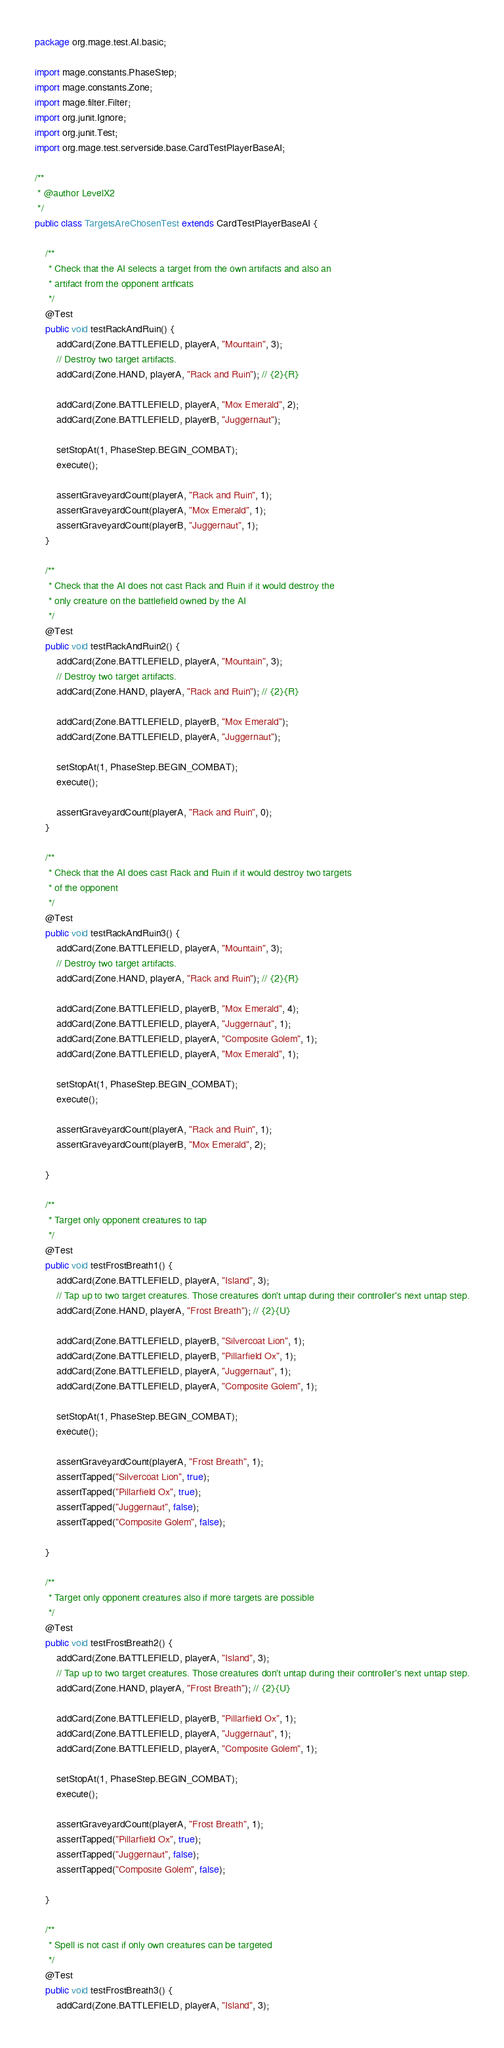Convert code to text. <code><loc_0><loc_0><loc_500><loc_500><_Java_>package org.mage.test.AI.basic;

import mage.constants.PhaseStep;
import mage.constants.Zone;
import mage.filter.Filter;
import org.junit.Ignore;
import org.junit.Test;
import org.mage.test.serverside.base.CardTestPlayerBaseAI;

/**
 * @author LevelX2
 */
public class TargetsAreChosenTest extends CardTestPlayerBaseAI {

    /**
     * Check that the AI selects a target from the own artifacts and also an
     * artifact from the opponent artficats
     */
    @Test
    public void testRackAndRuin() {
        addCard(Zone.BATTLEFIELD, playerA, "Mountain", 3);
        // Destroy two target artifacts.
        addCard(Zone.HAND, playerA, "Rack and Ruin"); // {2}{R}

        addCard(Zone.BATTLEFIELD, playerA, "Mox Emerald", 2);
        addCard(Zone.BATTLEFIELD, playerB, "Juggernaut");

        setStopAt(1, PhaseStep.BEGIN_COMBAT);
        execute();

        assertGraveyardCount(playerA, "Rack and Ruin", 1);
        assertGraveyardCount(playerA, "Mox Emerald", 1);
        assertGraveyardCount(playerB, "Juggernaut", 1);
    }

    /**
     * Check that the AI does not cast Rack and Ruin if it would destroy the
     * only creature on the battlefield owned by the AI
     */
    @Test
    public void testRackAndRuin2() {
        addCard(Zone.BATTLEFIELD, playerA, "Mountain", 3);
        // Destroy two target artifacts.
        addCard(Zone.HAND, playerA, "Rack and Ruin"); // {2}{R}

        addCard(Zone.BATTLEFIELD, playerB, "Mox Emerald");
        addCard(Zone.BATTLEFIELD, playerA, "Juggernaut");

        setStopAt(1, PhaseStep.BEGIN_COMBAT);
        execute();

        assertGraveyardCount(playerA, "Rack and Ruin", 0);
    }

    /**
     * Check that the AI does cast Rack and Ruin if it would destroy two targets
     * of the opponent
     */
    @Test
    public void testRackAndRuin3() {
        addCard(Zone.BATTLEFIELD, playerA, "Mountain", 3);
        // Destroy two target artifacts.
        addCard(Zone.HAND, playerA, "Rack and Ruin"); // {2}{R}

        addCard(Zone.BATTLEFIELD, playerB, "Mox Emerald", 4);
        addCard(Zone.BATTLEFIELD, playerA, "Juggernaut", 1);
        addCard(Zone.BATTLEFIELD, playerA, "Composite Golem", 1);
        addCard(Zone.BATTLEFIELD, playerA, "Mox Emerald", 1);

        setStopAt(1, PhaseStep.BEGIN_COMBAT);
        execute();

        assertGraveyardCount(playerA, "Rack and Ruin", 1);
        assertGraveyardCount(playerB, "Mox Emerald", 2);

    }

    /**
     * Target only opponent creatures to tap
     */
    @Test
    public void testFrostBreath1() {
        addCard(Zone.BATTLEFIELD, playerA, "Island", 3);
        // Tap up to two target creatures. Those creatures don't untap during their controller's next untap step.
        addCard(Zone.HAND, playerA, "Frost Breath"); // {2}{U}

        addCard(Zone.BATTLEFIELD, playerB, "Silvercoat Lion", 1);
        addCard(Zone.BATTLEFIELD, playerB, "Pillarfield Ox", 1);
        addCard(Zone.BATTLEFIELD, playerA, "Juggernaut", 1);
        addCard(Zone.BATTLEFIELD, playerA, "Composite Golem", 1);

        setStopAt(1, PhaseStep.BEGIN_COMBAT);
        execute();

        assertGraveyardCount(playerA, "Frost Breath", 1);
        assertTapped("Silvercoat Lion", true);
        assertTapped("Pillarfield Ox", true);
        assertTapped("Juggernaut", false);
        assertTapped("Composite Golem", false);

    }

    /**
     * Target only opponent creatures also if more targets are possible
     */
    @Test
    public void testFrostBreath2() {
        addCard(Zone.BATTLEFIELD, playerA, "Island", 3);
        // Tap up to two target creatures. Those creatures don't untap during their controller's next untap step.
        addCard(Zone.HAND, playerA, "Frost Breath"); // {2}{U}

        addCard(Zone.BATTLEFIELD, playerB, "Pillarfield Ox", 1);
        addCard(Zone.BATTLEFIELD, playerA, "Juggernaut", 1);
        addCard(Zone.BATTLEFIELD, playerA, "Composite Golem", 1);

        setStopAt(1, PhaseStep.BEGIN_COMBAT);
        execute();

        assertGraveyardCount(playerA, "Frost Breath", 1);
        assertTapped("Pillarfield Ox", true);
        assertTapped("Juggernaut", false);
        assertTapped("Composite Golem", false);

    }

    /**
     * Spell is not cast if only own creatures can be targeted
     */
    @Test
    public void testFrostBreath3() {
        addCard(Zone.BATTLEFIELD, playerA, "Island", 3);</code> 